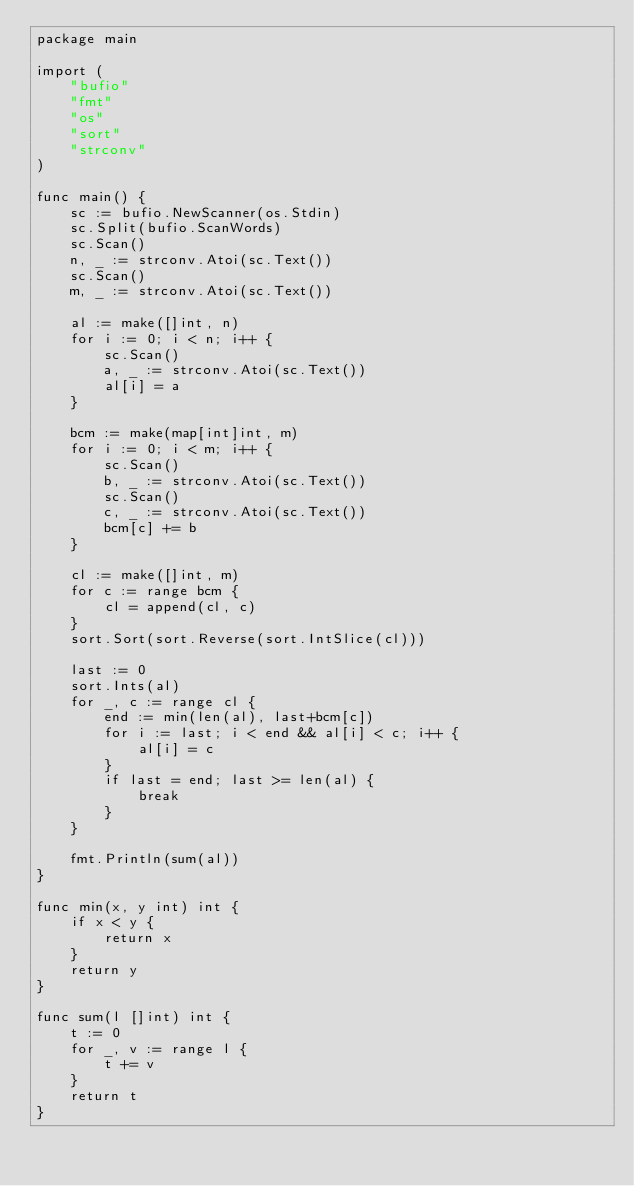<code> <loc_0><loc_0><loc_500><loc_500><_Go_>package main

import (
	"bufio"
	"fmt"
	"os"
	"sort"
	"strconv"
)

func main() {
	sc := bufio.NewScanner(os.Stdin)
	sc.Split(bufio.ScanWords)
	sc.Scan()
	n, _ := strconv.Atoi(sc.Text())
	sc.Scan()
	m, _ := strconv.Atoi(sc.Text())

	al := make([]int, n)
	for i := 0; i < n; i++ {
		sc.Scan()
		a, _ := strconv.Atoi(sc.Text())
		al[i] = a
	}

	bcm := make(map[int]int, m)
	for i := 0; i < m; i++ {
		sc.Scan()
		b, _ := strconv.Atoi(sc.Text())
		sc.Scan()
		c, _ := strconv.Atoi(sc.Text())
		bcm[c] += b
	}

	cl := make([]int, m)
	for c := range bcm {
		cl = append(cl, c)
	}
	sort.Sort(sort.Reverse(sort.IntSlice(cl)))

	last := 0
	sort.Ints(al)
	for _, c := range cl {
		end := min(len(al), last+bcm[c])
		for i := last; i < end && al[i] < c; i++ {
			al[i] = c
		}
		if last = end; last >= len(al) {
			break
		}
	}

	fmt.Println(sum(al))
}

func min(x, y int) int {
	if x < y {
		return x
	}
	return y
}

func sum(l []int) int {
	t := 0
	for _, v := range l {
		t += v
	}
	return t
}
</code> 